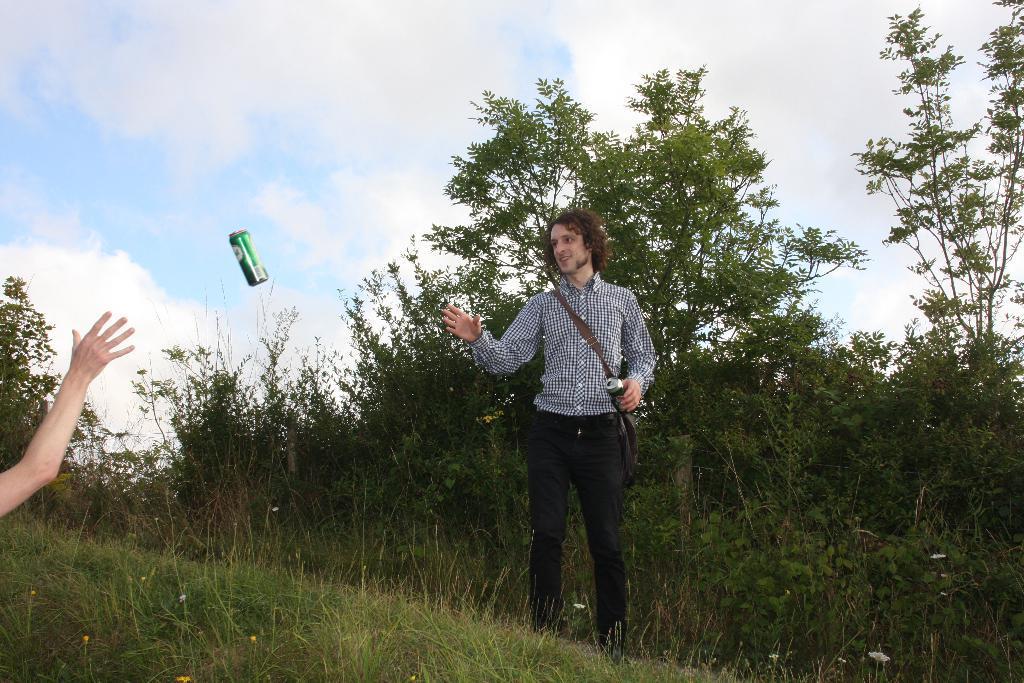Describe this image in one or two sentences. In the image there is a man in checkered shirt and black pant showing hand. there is a soft drink tin in the middle of air and a behind visible on the left side, the land is covered with grass in the front and trees in the background and above its sky with clouds. 